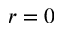<formula> <loc_0><loc_0><loc_500><loc_500>r = 0</formula> 